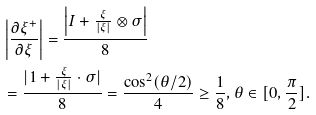<formula> <loc_0><loc_0><loc_500><loc_500>& \left | \frac { \partial \xi ^ { + } } { \partial \xi } \right | = \frac { \left | I + \frac { \xi } { | \xi | } \otimes \sigma \right | } { 8 } \\ & = \frac { | 1 + \frac { \xi } { | \xi | } \cdot \sigma | } { 8 } = \frac { \cos ^ { 2 } ( \theta / 2 ) } { 4 } \geq \frac { 1 } { 8 } , \theta \in [ 0 , \frac { \pi } { 2 } ] .</formula> 